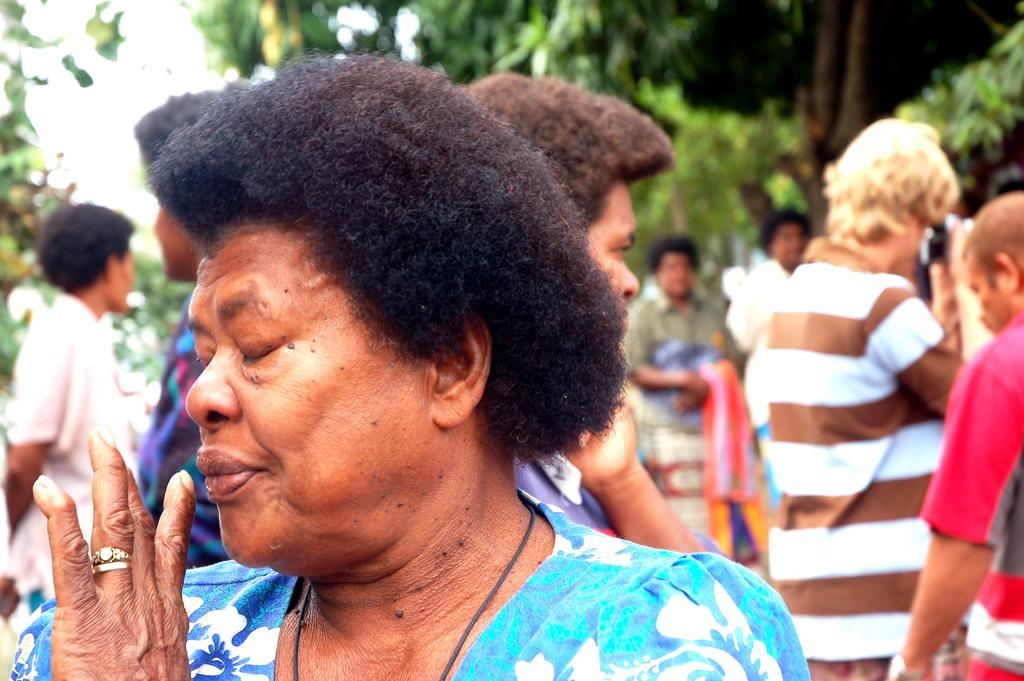Who is the main subject in the image? There is a woman in the image. What is the woman wearing? The woman is wearing a blue dress. What can be seen in the background of the image? There are many people and trees in the background of the image. What type of plantation can be seen in the image? There is no plantation present in the image. Are there any police officers visible in the image? There is no mention of police officers in the image. What is the woman using to hammer something in the image? There is no hammer present in the image. 